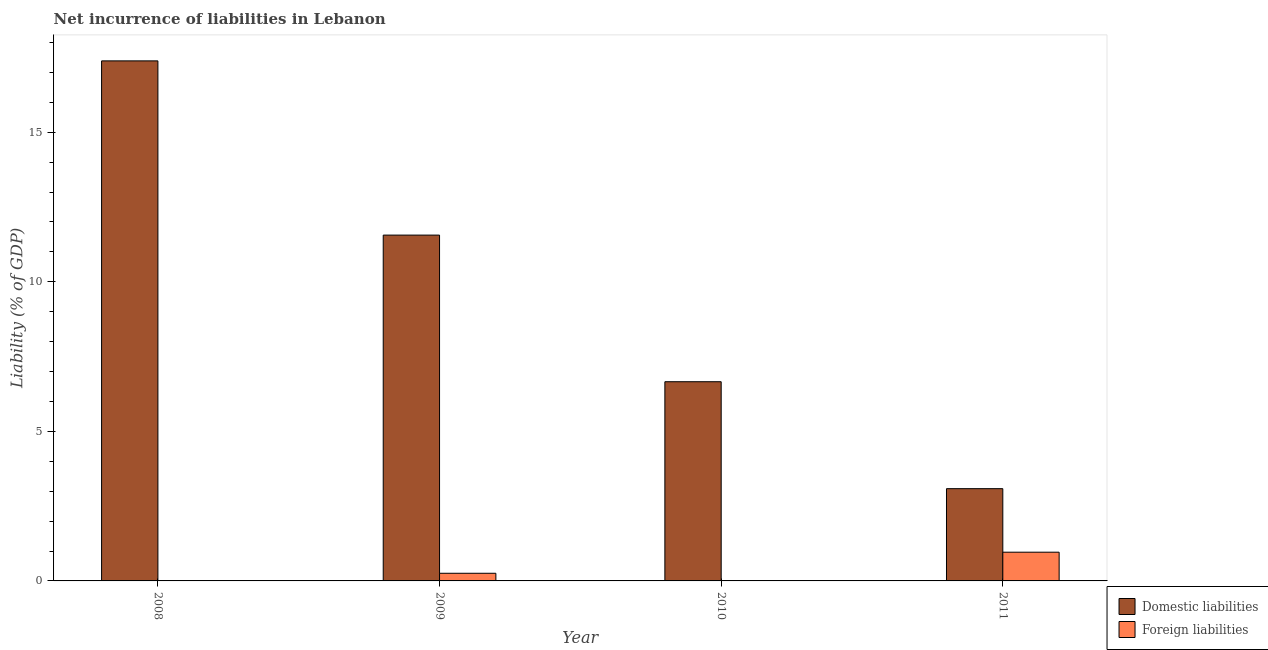Are the number of bars per tick equal to the number of legend labels?
Keep it short and to the point. No. Are the number of bars on each tick of the X-axis equal?
Offer a terse response. No. How many bars are there on the 3rd tick from the left?
Keep it short and to the point. 1. What is the incurrence of domestic liabilities in 2009?
Provide a succinct answer. 11.56. Across all years, what is the maximum incurrence of domestic liabilities?
Your answer should be very brief. 17.38. In which year was the incurrence of foreign liabilities maximum?
Offer a very short reply. 2011. What is the total incurrence of domestic liabilities in the graph?
Provide a short and direct response. 38.68. What is the difference between the incurrence of domestic liabilities in 2008 and that in 2009?
Offer a very short reply. 5.82. What is the difference between the incurrence of foreign liabilities in 2011 and the incurrence of domestic liabilities in 2010?
Ensure brevity in your answer.  0.96. What is the average incurrence of foreign liabilities per year?
Give a very brief answer. 0.3. In how many years, is the incurrence of foreign liabilities greater than 1 %?
Offer a terse response. 0. What is the ratio of the incurrence of foreign liabilities in 2009 to that in 2011?
Keep it short and to the point. 0.27. Is the incurrence of domestic liabilities in 2009 less than that in 2011?
Your answer should be compact. No. Is the difference between the incurrence of domestic liabilities in 2008 and 2009 greater than the difference between the incurrence of foreign liabilities in 2008 and 2009?
Keep it short and to the point. No. What is the difference between the highest and the second highest incurrence of domestic liabilities?
Keep it short and to the point. 5.82. What is the difference between the highest and the lowest incurrence of foreign liabilities?
Offer a very short reply. 0.96. How many bars are there?
Provide a short and direct response. 6. How many years are there in the graph?
Make the answer very short. 4. Are the values on the major ticks of Y-axis written in scientific E-notation?
Your answer should be compact. No. Where does the legend appear in the graph?
Provide a short and direct response. Bottom right. How are the legend labels stacked?
Provide a short and direct response. Vertical. What is the title of the graph?
Your answer should be compact. Net incurrence of liabilities in Lebanon. What is the label or title of the X-axis?
Your answer should be compact. Year. What is the label or title of the Y-axis?
Keep it short and to the point. Liability (% of GDP). What is the Liability (% of GDP) in Domestic liabilities in 2008?
Provide a short and direct response. 17.38. What is the Liability (% of GDP) in Foreign liabilities in 2008?
Give a very brief answer. 0. What is the Liability (% of GDP) of Domestic liabilities in 2009?
Your answer should be very brief. 11.56. What is the Liability (% of GDP) in Foreign liabilities in 2009?
Your answer should be very brief. 0.26. What is the Liability (% of GDP) of Domestic liabilities in 2010?
Give a very brief answer. 6.66. What is the Liability (% of GDP) in Domestic liabilities in 2011?
Your response must be concise. 3.08. What is the Liability (% of GDP) of Foreign liabilities in 2011?
Keep it short and to the point. 0.96. Across all years, what is the maximum Liability (% of GDP) of Domestic liabilities?
Offer a terse response. 17.38. Across all years, what is the maximum Liability (% of GDP) of Foreign liabilities?
Your response must be concise. 0.96. Across all years, what is the minimum Liability (% of GDP) of Domestic liabilities?
Ensure brevity in your answer.  3.08. What is the total Liability (% of GDP) of Domestic liabilities in the graph?
Your answer should be compact. 38.68. What is the total Liability (% of GDP) in Foreign liabilities in the graph?
Provide a succinct answer. 1.22. What is the difference between the Liability (% of GDP) of Domestic liabilities in 2008 and that in 2009?
Your response must be concise. 5.82. What is the difference between the Liability (% of GDP) in Domestic liabilities in 2008 and that in 2010?
Your response must be concise. 10.72. What is the difference between the Liability (% of GDP) of Domestic liabilities in 2008 and that in 2011?
Keep it short and to the point. 14.3. What is the difference between the Liability (% of GDP) in Domestic liabilities in 2009 and that in 2010?
Your answer should be very brief. 4.9. What is the difference between the Liability (% of GDP) in Domestic liabilities in 2009 and that in 2011?
Keep it short and to the point. 8.48. What is the difference between the Liability (% of GDP) of Foreign liabilities in 2009 and that in 2011?
Ensure brevity in your answer.  -0.7. What is the difference between the Liability (% of GDP) of Domestic liabilities in 2010 and that in 2011?
Offer a very short reply. 3.57. What is the difference between the Liability (% of GDP) of Domestic liabilities in 2008 and the Liability (% of GDP) of Foreign liabilities in 2009?
Your response must be concise. 17.13. What is the difference between the Liability (% of GDP) of Domestic liabilities in 2008 and the Liability (% of GDP) of Foreign liabilities in 2011?
Ensure brevity in your answer.  16.42. What is the difference between the Liability (% of GDP) in Domestic liabilities in 2009 and the Liability (% of GDP) in Foreign liabilities in 2011?
Your answer should be compact. 10.6. What is the difference between the Liability (% of GDP) in Domestic liabilities in 2010 and the Liability (% of GDP) in Foreign liabilities in 2011?
Offer a terse response. 5.7. What is the average Liability (% of GDP) of Domestic liabilities per year?
Your response must be concise. 9.67. What is the average Liability (% of GDP) of Foreign liabilities per year?
Provide a short and direct response. 0.3. In the year 2009, what is the difference between the Liability (% of GDP) in Domestic liabilities and Liability (% of GDP) in Foreign liabilities?
Provide a short and direct response. 11.3. In the year 2011, what is the difference between the Liability (% of GDP) in Domestic liabilities and Liability (% of GDP) in Foreign liabilities?
Your answer should be very brief. 2.12. What is the ratio of the Liability (% of GDP) in Domestic liabilities in 2008 to that in 2009?
Give a very brief answer. 1.5. What is the ratio of the Liability (% of GDP) of Domestic liabilities in 2008 to that in 2010?
Offer a terse response. 2.61. What is the ratio of the Liability (% of GDP) of Domestic liabilities in 2008 to that in 2011?
Make the answer very short. 5.64. What is the ratio of the Liability (% of GDP) in Domestic liabilities in 2009 to that in 2010?
Your answer should be very brief. 1.74. What is the ratio of the Liability (% of GDP) in Domestic liabilities in 2009 to that in 2011?
Your answer should be compact. 3.75. What is the ratio of the Liability (% of GDP) in Foreign liabilities in 2009 to that in 2011?
Make the answer very short. 0.27. What is the ratio of the Liability (% of GDP) of Domestic liabilities in 2010 to that in 2011?
Your answer should be very brief. 2.16. What is the difference between the highest and the second highest Liability (% of GDP) in Domestic liabilities?
Give a very brief answer. 5.82. What is the difference between the highest and the lowest Liability (% of GDP) in Domestic liabilities?
Ensure brevity in your answer.  14.3. 